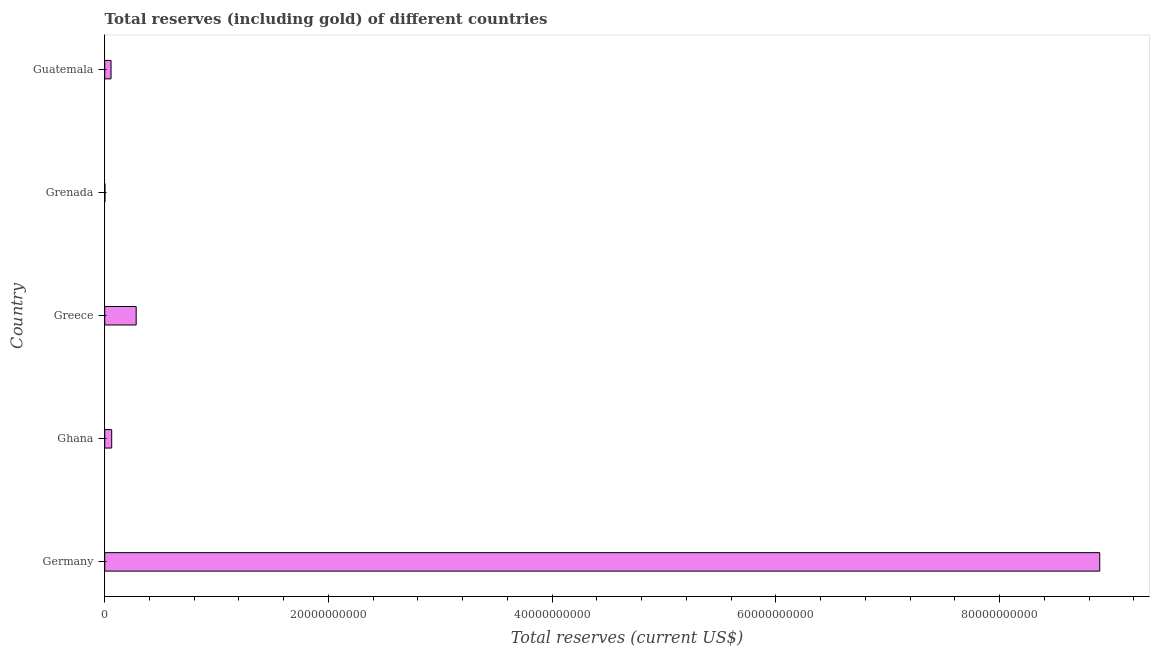Does the graph contain any zero values?
Give a very brief answer. No. What is the title of the graph?
Provide a succinct answer. Total reserves (including gold) of different countries. What is the label or title of the X-axis?
Ensure brevity in your answer.  Total reserves (current US$). What is the label or title of the Y-axis?
Your answer should be compact. Country. What is the total reserves (including gold) in Ghana?
Make the answer very short. 6.24e+08. Across all countries, what is the maximum total reserves (including gold)?
Offer a terse response. 8.89e+1. Across all countries, what is the minimum total reserves (including gold)?
Your response must be concise. 2.06e+07. In which country was the total reserves (including gold) minimum?
Keep it short and to the point. Grenada. What is the sum of the total reserves (including gold)?
Offer a very short reply. 9.30e+1. What is the difference between the total reserves (including gold) in Greece and Guatemala?
Your answer should be compact. 2.25e+09. What is the average total reserves (including gold) per country?
Make the answer very short. 1.86e+1. What is the median total reserves (including gold)?
Ensure brevity in your answer.  6.24e+08. What is the ratio of the total reserves (including gold) in Greece to that in Grenada?
Provide a short and direct response. 136.73. Is the total reserves (including gold) in Ghana less than that in Grenada?
Provide a succinct answer. No. What is the difference between the highest and the second highest total reserves (including gold)?
Your response must be concise. 8.61e+1. What is the difference between the highest and the lowest total reserves (including gold)?
Keep it short and to the point. 8.89e+1. Are all the bars in the graph horizontal?
Make the answer very short. Yes. What is the difference between two consecutive major ticks on the X-axis?
Make the answer very short. 2.00e+1. Are the values on the major ticks of X-axis written in scientific E-notation?
Offer a very short reply. No. What is the Total reserves (current US$) of Germany?
Give a very brief answer. 8.89e+1. What is the Total reserves (current US$) in Ghana?
Keep it short and to the point. 6.24e+08. What is the Total reserves (current US$) in Greece?
Ensure brevity in your answer.  2.81e+09. What is the Total reserves (current US$) of Grenada?
Your response must be concise. 2.06e+07. What is the Total reserves (current US$) of Guatemala?
Ensure brevity in your answer.  5.66e+08. What is the difference between the Total reserves (current US$) in Germany and Ghana?
Your response must be concise. 8.83e+1. What is the difference between the Total reserves (current US$) in Germany and Greece?
Ensure brevity in your answer.  8.61e+1. What is the difference between the Total reserves (current US$) in Germany and Grenada?
Offer a terse response. 8.89e+1. What is the difference between the Total reserves (current US$) in Germany and Guatemala?
Ensure brevity in your answer.  8.84e+1. What is the difference between the Total reserves (current US$) in Ghana and Greece?
Keep it short and to the point. -2.19e+09. What is the difference between the Total reserves (current US$) in Ghana and Grenada?
Your answer should be very brief. 6.03e+08. What is the difference between the Total reserves (current US$) in Ghana and Guatemala?
Offer a terse response. 5.77e+07. What is the difference between the Total reserves (current US$) in Greece and Grenada?
Ensure brevity in your answer.  2.79e+09. What is the difference between the Total reserves (current US$) in Greece and Guatemala?
Make the answer very short. 2.25e+09. What is the difference between the Total reserves (current US$) in Grenada and Guatemala?
Provide a short and direct response. -5.46e+08. What is the ratio of the Total reserves (current US$) in Germany to that in Ghana?
Offer a very short reply. 142.54. What is the ratio of the Total reserves (current US$) in Germany to that in Greece?
Your answer should be very brief. 31.63. What is the ratio of the Total reserves (current US$) in Germany to that in Grenada?
Provide a short and direct response. 4324.82. What is the ratio of the Total reserves (current US$) in Germany to that in Guatemala?
Offer a very short reply. 157.06. What is the ratio of the Total reserves (current US$) in Ghana to that in Greece?
Make the answer very short. 0.22. What is the ratio of the Total reserves (current US$) in Ghana to that in Grenada?
Your response must be concise. 30.34. What is the ratio of the Total reserves (current US$) in Ghana to that in Guatemala?
Your answer should be very brief. 1.1. What is the ratio of the Total reserves (current US$) in Greece to that in Grenada?
Ensure brevity in your answer.  136.73. What is the ratio of the Total reserves (current US$) in Greece to that in Guatemala?
Offer a very short reply. 4.96. What is the ratio of the Total reserves (current US$) in Grenada to that in Guatemala?
Ensure brevity in your answer.  0.04. 